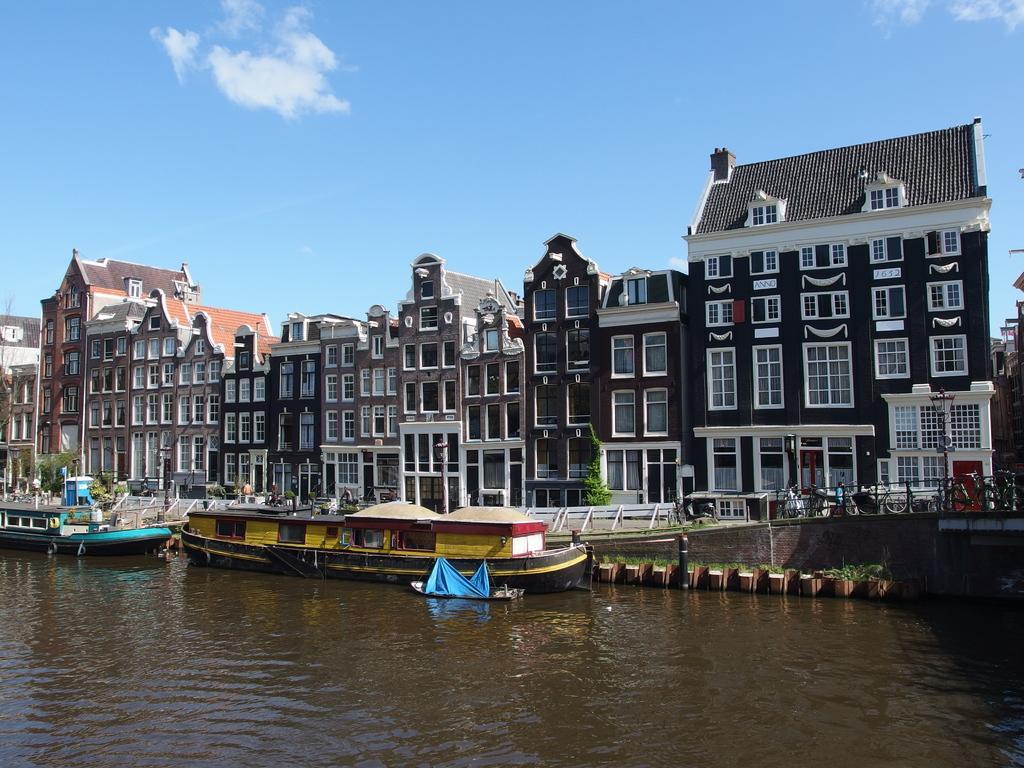Describe this image in one or two sentences. In this picture we can see few boats on the water, in the background we can find few people, and buildings, and also we can see trees. 